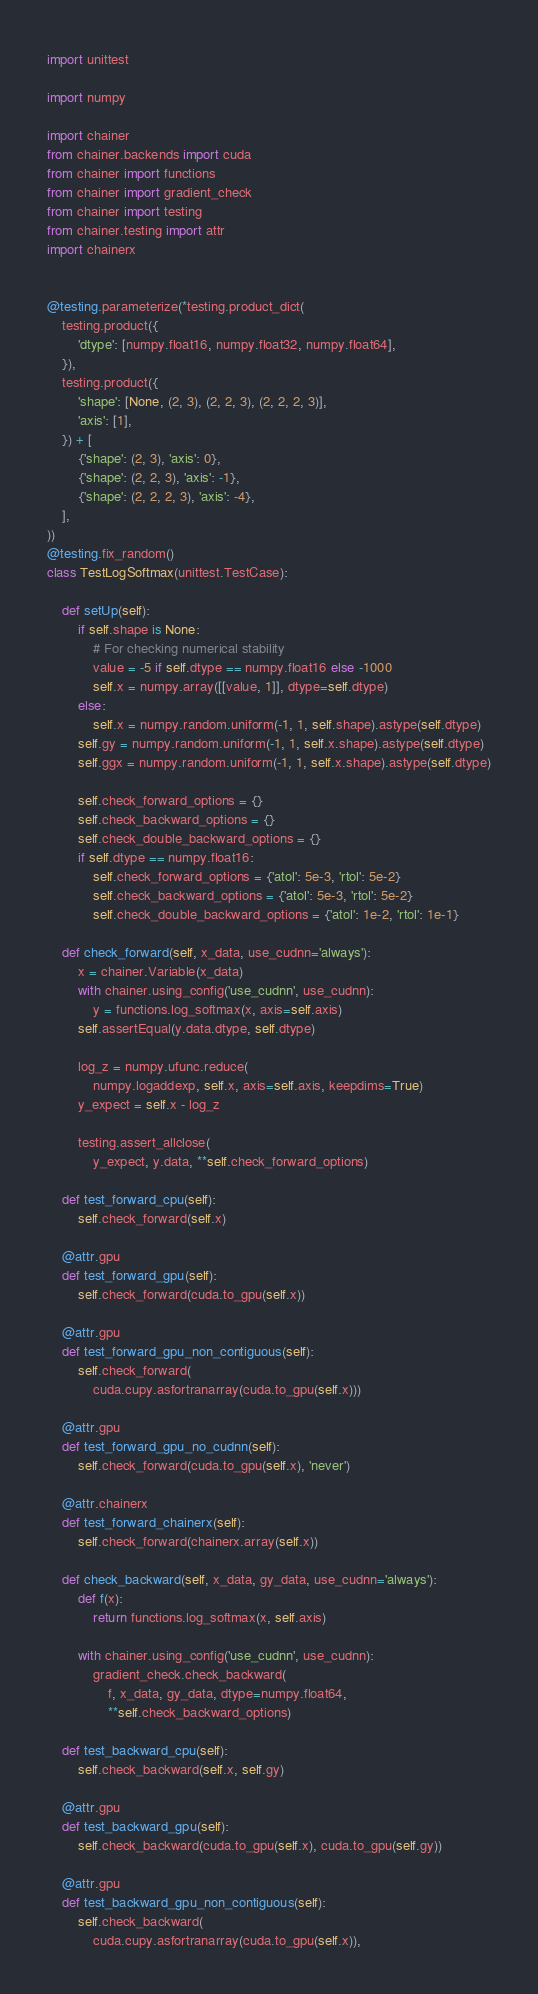Convert code to text. <code><loc_0><loc_0><loc_500><loc_500><_Python_>import unittest

import numpy

import chainer
from chainer.backends import cuda
from chainer import functions
from chainer import gradient_check
from chainer import testing
from chainer.testing import attr
import chainerx


@testing.parameterize(*testing.product_dict(
    testing.product({
        'dtype': [numpy.float16, numpy.float32, numpy.float64],
    }),
    testing.product({
        'shape': [None, (2, 3), (2, 2, 3), (2, 2, 2, 3)],
        'axis': [1],
    }) + [
        {'shape': (2, 3), 'axis': 0},
        {'shape': (2, 2, 3), 'axis': -1},
        {'shape': (2, 2, 2, 3), 'axis': -4},
    ],
))
@testing.fix_random()
class TestLogSoftmax(unittest.TestCase):

    def setUp(self):
        if self.shape is None:
            # For checking numerical stability
            value = -5 if self.dtype == numpy.float16 else -1000
            self.x = numpy.array([[value, 1]], dtype=self.dtype)
        else:
            self.x = numpy.random.uniform(-1, 1, self.shape).astype(self.dtype)
        self.gy = numpy.random.uniform(-1, 1, self.x.shape).astype(self.dtype)
        self.ggx = numpy.random.uniform(-1, 1, self.x.shape).astype(self.dtype)

        self.check_forward_options = {}
        self.check_backward_options = {}
        self.check_double_backward_options = {}
        if self.dtype == numpy.float16:
            self.check_forward_options = {'atol': 5e-3, 'rtol': 5e-2}
            self.check_backward_options = {'atol': 5e-3, 'rtol': 5e-2}
            self.check_double_backward_options = {'atol': 1e-2, 'rtol': 1e-1}

    def check_forward(self, x_data, use_cudnn='always'):
        x = chainer.Variable(x_data)
        with chainer.using_config('use_cudnn', use_cudnn):
            y = functions.log_softmax(x, axis=self.axis)
        self.assertEqual(y.data.dtype, self.dtype)

        log_z = numpy.ufunc.reduce(
            numpy.logaddexp, self.x, axis=self.axis, keepdims=True)
        y_expect = self.x - log_z

        testing.assert_allclose(
            y_expect, y.data, **self.check_forward_options)

    def test_forward_cpu(self):
        self.check_forward(self.x)

    @attr.gpu
    def test_forward_gpu(self):
        self.check_forward(cuda.to_gpu(self.x))

    @attr.gpu
    def test_forward_gpu_non_contiguous(self):
        self.check_forward(
            cuda.cupy.asfortranarray(cuda.to_gpu(self.x)))

    @attr.gpu
    def test_forward_gpu_no_cudnn(self):
        self.check_forward(cuda.to_gpu(self.x), 'never')

    @attr.chainerx
    def test_forward_chainerx(self):
        self.check_forward(chainerx.array(self.x))

    def check_backward(self, x_data, gy_data, use_cudnn='always'):
        def f(x):
            return functions.log_softmax(x, self.axis)

        with chainer.using_config('use_cudnn', use_cudnn):
            gradient_check.check_backward(
                f, x_data, gy_data, dtype=numpy.float64,
                **self.check_backward_options)

    def test_backward_cpu(self):
        self.check_backward(self.x, self.gy)

    @attr.gpu
    def test_backward_gpu(self):
        self.check_backward(cuda.to_gpu(self.x), cuda.to_gpu(self.gy))

    @attr.gpu
    def test_backward_gpu_non_contiguous(self):
        self.check_backward(
            cuda.cupy.asfortranarray(cuda.to_gpu(self.x)),</code> 